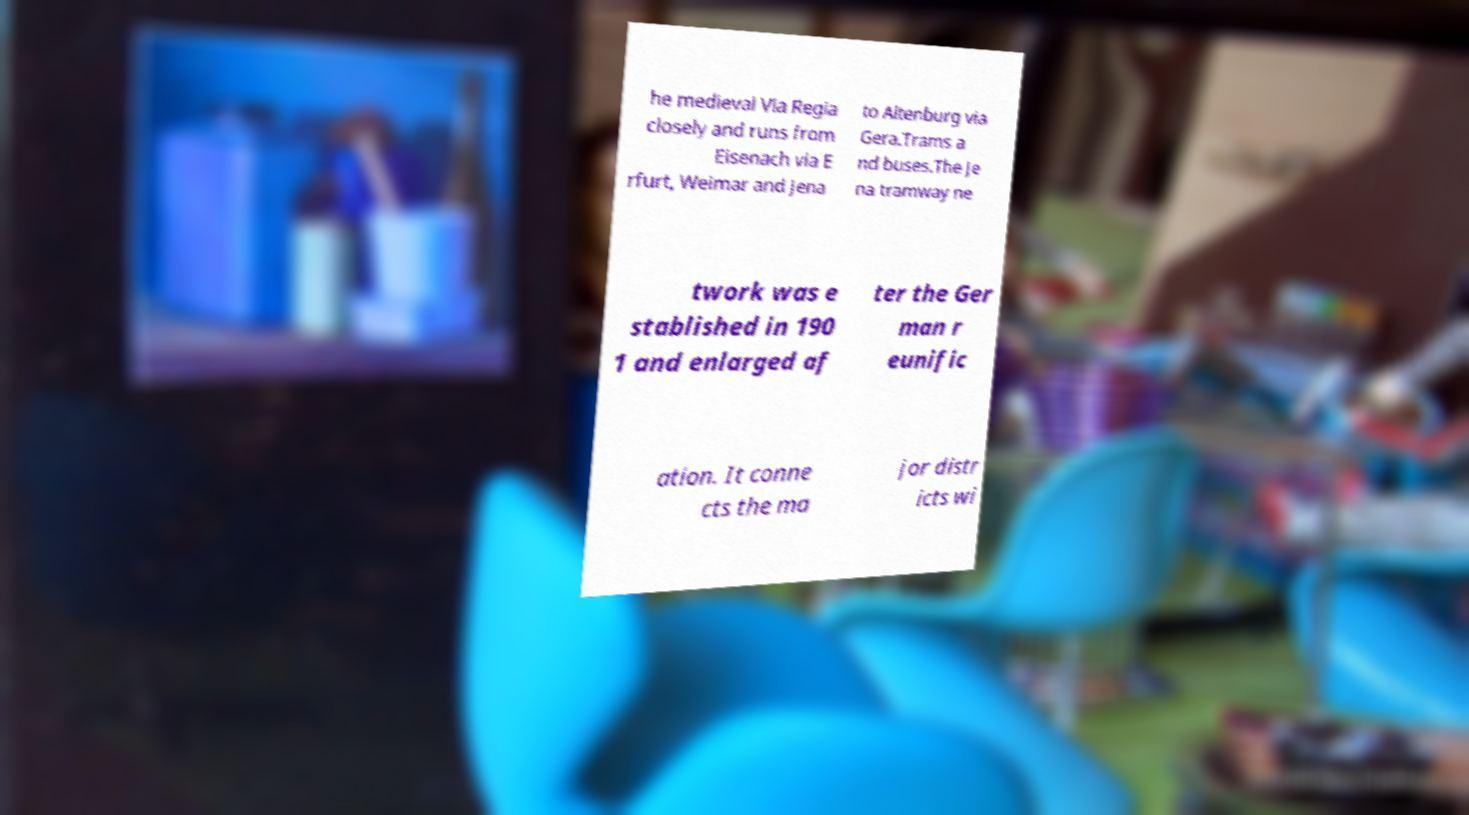Can you accurately transcribe the text from the provided image for me? he medieval Via Regia closely and runs from Eisenach via E rfurt, Weimar and Jena to Altenburg via Gera.Trams a nd buses.The Je na tramway ne twork was e stablished in 190 1 and enlarged af ter the Ger man r eunific ation. It conne cts the ma jor distr icts wi 